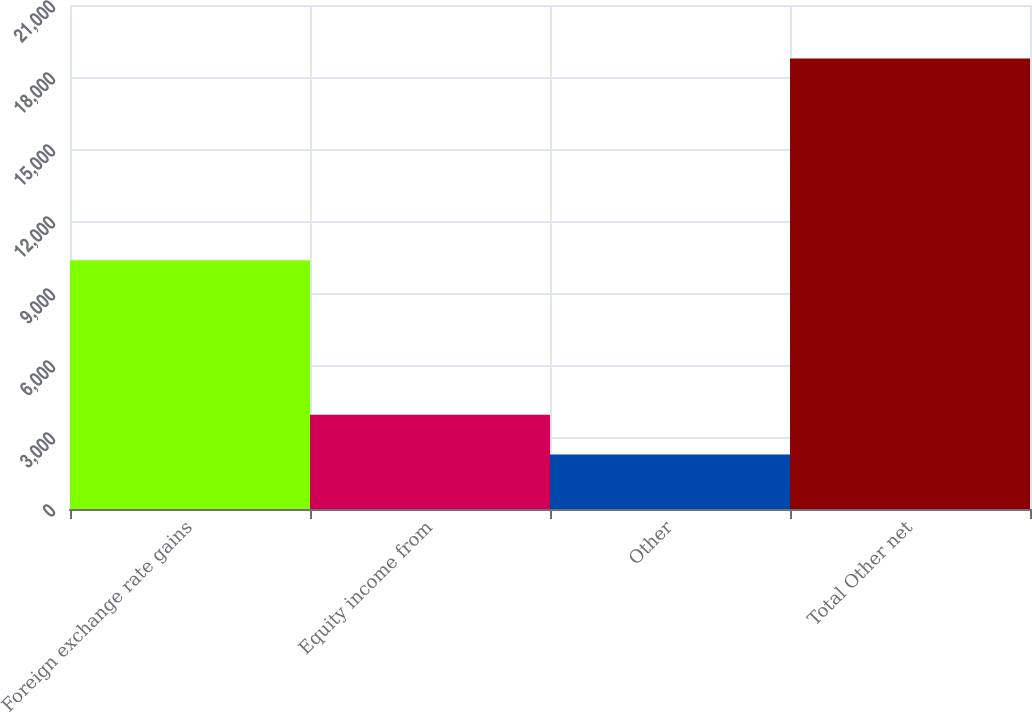Convert chart to OTSL. <chart><loc_0><loc_0><loc_500><loc_500><bar_chart><fcel>Foreign exchange rate gains<fcel>Equity income from<fcel>Other<fcel>Total Other net<nl><fcel>10367<fcel>3924.5<fcel>2275<fcel>18770<nl></chart> 